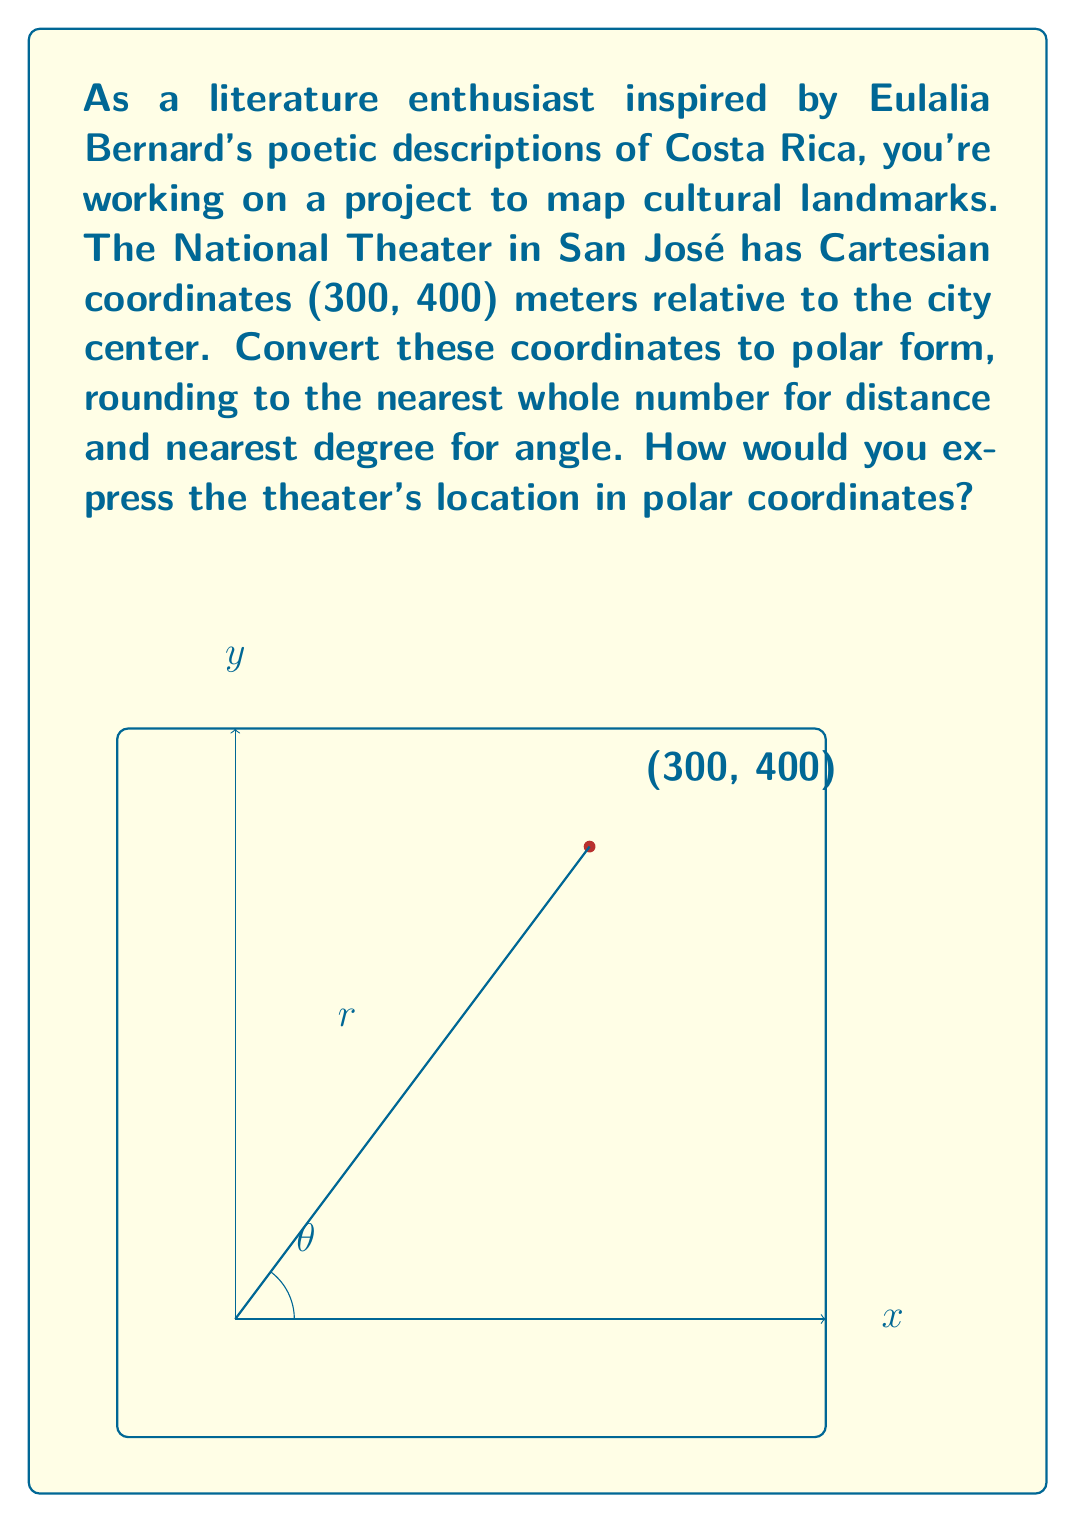Show me your answer to this math problem. To convert from Cartesian coordinates $(x, y)$ to polar coordinates $(r, \theta)$, we use the following formulas:

1. $r = \sqrt{x^2 + y^2}$
2. $\theta = \tan^{-1}(\frac{y}{x})$

For the National Theater at (300, 400):

1. Calculate $r$:
   $r = \sqrt{300^2 + 400^2}$
   $r = \sqrt{90,000 + 160,000}$
   $r = \sqrt{250,000}$
   $r = 500$ meters

2. Calculate $\theta$:
   $\theta = \tan^{-1}(\frac{400}{300})$
   $\theta = \tan^{-1}(1.3333...)$
   $\theta \approx 53.13010...$ degrees

3. Rounding to the nearest whole number for distance and nearest degree for angle:
   $r = 500$ meters
   $\theta = 53°$

Therefore, the polar coordinates of the National Theater are $(500, 53°)$.
Answer: $(500, 53°)$ 